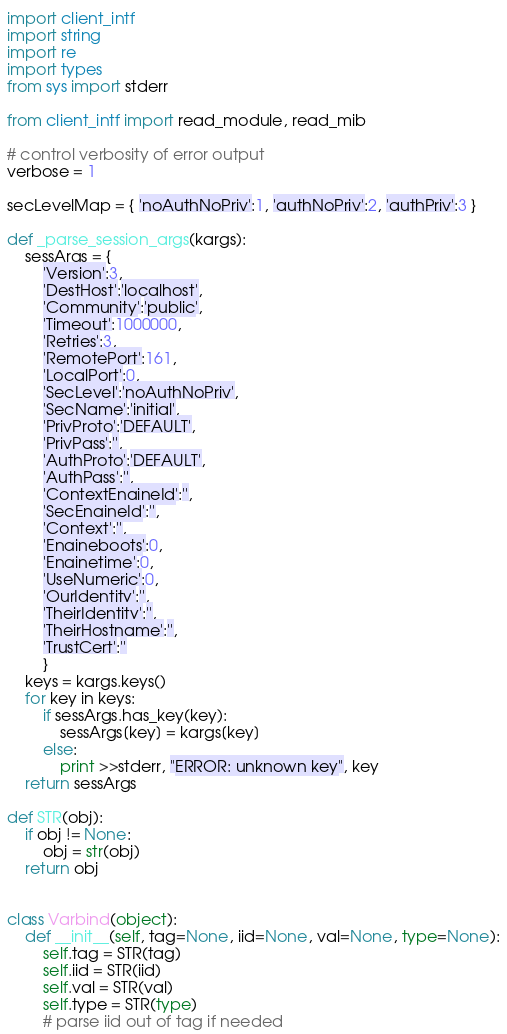Convert code to text. <code><loc_0><loc_0><loc_500><loc_500><_Python_>import client_intf
import string
import re
import types
from sys import stderr

from client_intf import read_module, read_mib

# control verbosity of error output
verbose = 1

secLevelMap = { 'noAuthNoPriv':1, 'authNoPriv':2, 'authPriv':3 }

def _parse_session_args(kargs):
    sessArgs = {
        'Version':3,
        'DestHost':'localhost',
        'Community':'public',
        'Timeout':1000000,
        'Retries':3,
        'RemotePort':161,
        'LocalPort':0,
        'SecLevel':'noAuthNoPriv',
        'SecName':'initial',
        'PrivProto':'DEFAULT',
        'PrivPass':'',
        'AuthProto':'DEFAULT',
        'AuthPass':'',
        'ContextEngineId':'',
        'SecEngineId':'',
        'Context':'',
        'Engineboots':0,
        'Enginetime':0,
        'UseNumeric':0,
        'OurIdentity':'',
        'TheirIdentity':'',
        'TheirHostname':'',
        'TrustCert':''
        }
    keys = kargs.keys()
    for key in keys:
        if sessArgs.has_key(key):
            sessArgs[key] = kargs[key]
        else:
            print >>stderr, "ERROR: unknown key", key
    return sessArgs

def STR(obj):
    if obj != None:
        obj = str(obj)
    return obj
    

class Varbind(object):
    def __init__(self, tag=None, iid=None, val=None, type=None):
        self.tag = STR(tag)
        self.iid = STR(iid)
        self.val = STR(val)
        self.type = STR(type)
        # parse iid out of tag if needed</code> 